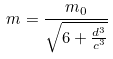<formula> <loc_0><loc_0><loc_500><loc_500>m = \frac { m _ { 0 } } { \sqrt { 6 + \frac { d ^ { 3 } } { c ^ { 3 } } } }</formula> 